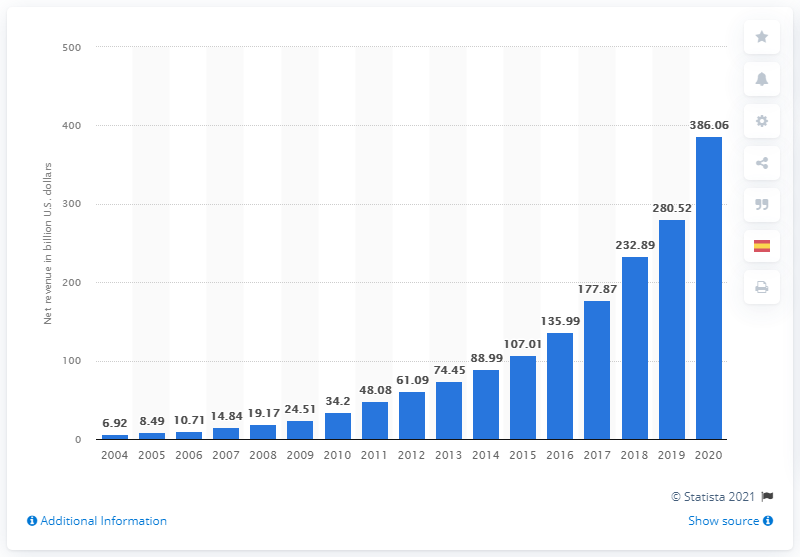Indicate a few pertinent items in this graphic. In the most recent fiscal year, Amazon's net revenue was 386.06 billion dollars. 